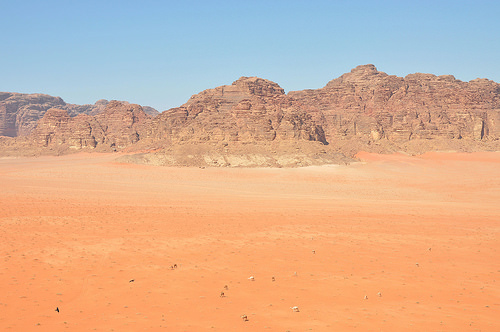<image>
Is the rock on the sky? No. The rock is not positioned on the sky. They may be near each other, but the rock is not supported by or resting on top of the sky. 